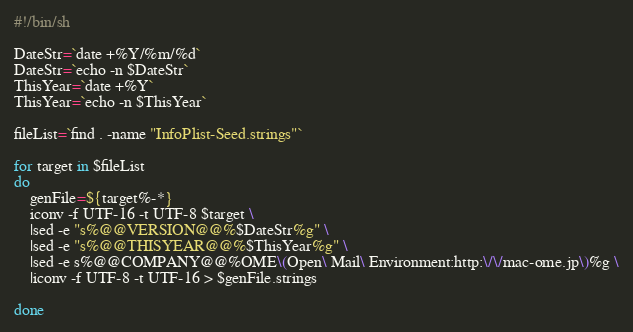<code> <loc_0><loc_0><loc_500><loc_500><_Bash_>#!/bin/sh

DateStr=`date +%Y/%m/%d`
DateStr=`echo -n $DateStr`
ThisYear=`date +%Y`
ThisYear=`echo -n $ThisYear`

fileList=`find . -name "InfoPlist-Seed.strings"`

for target in $fileList
do
	genFile=${target%-*}
	iconv -f UTF-16 -t UTF-8 $target \
	|sed -e "s%@@VERSION@@%$DateStr%g" \
	|sed -e "s%@@THISYEAR@@%$ThisYear%g" \
	|sed -e s%@@COMPANY@@%OME\(Open\ Mail\ Environment:http:\/\/mac-ome.jp\)%g \
	|iconv -f UTF-8 -t UTF-16 > $genFile.strings

done

</code> 